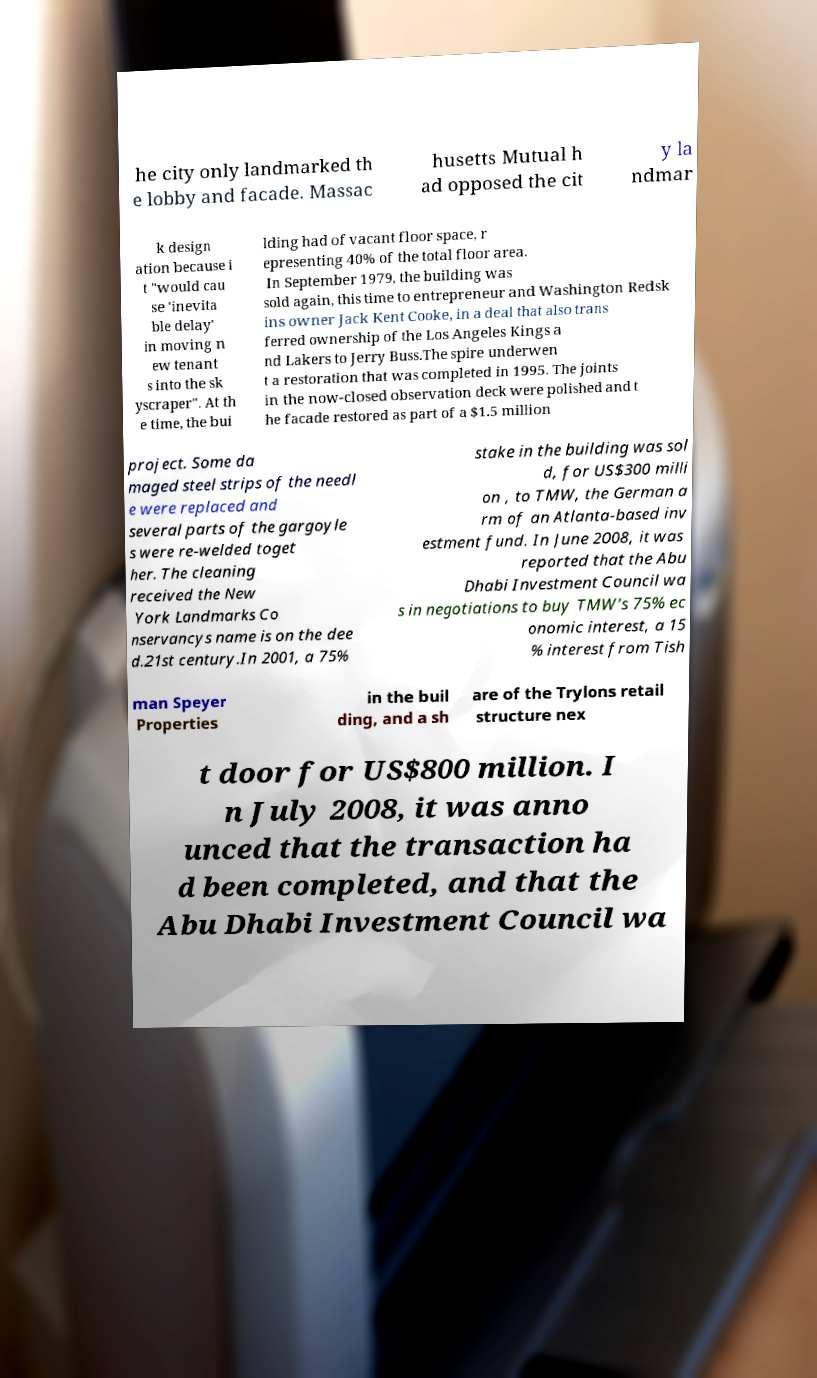What messages or text are displayed in this image? I need them in a readable, typed format. he city only landmarked th e lobby and facade. Massac husetts Mutual h ad opposed the cit y la ndmar k design ation because i t "would cau se 'inevita ble delay' in moving n ew tenant s into the sk yscraper". At th e time, the bui lding had of vacant floor space, r epresenting 40% of the total floor area. In September 1979, the building was sold again, this time to entrepreneur and Washington Redsk ins owner Jack Kent Cooke, in a deal that also trans ferred ownership of the Los Angeles Kings a nd Lakers to Jerry Buss.The spire underwen t a restoration that was completed in 1995. The joints in the now-closed observation deck were polished and t he facade restored as part of a $1.5 million project. Some da maged steel strips of the needl e were replaced and several parts of the gargoyle s were re-welded toget her. The cleaning received the New York Landmarks Co nservancys name is on the dee d.21st century.In 2001, a 75% stake in the building was sol d, for US$300 milli on , to TMW, the German a rm of an Atlanta-based inv estment fund. In June 2008, it was reported that the Abu Dhabi Investment Council wa s in negotiations to buy TMW's 75% ec onomic interest, a 15 % interest from Tish man Speyer Properties in the buil ding, and a sh are of the Trylons retail structure nex t door for US$800 million. I n July 2008, it was anno unced that the transaction ha d been completed, and that the Abu Dhabi Investment Council wa 